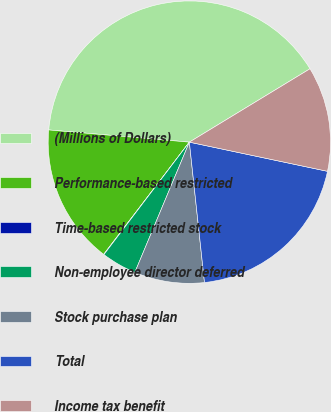Convert chart to OTSL. <chart><loc_0><loc_0><loc_500><loc_500><pie_chart><fcel>(Millions of Dollars)<fcel>Performance-based restricted<fcel>Time-based restricted stock<fcel>Non-employee director deferred<fcel>Stock purchase plan<fcel>Total<fcel>Income tax benefit<nl><fcel>39.93%<fcel>16.0%<fcel>0.04%<fcel>4.03%<fcel>8.02%<fcel>19.98%<fcel>12.01%<nl></chart> 